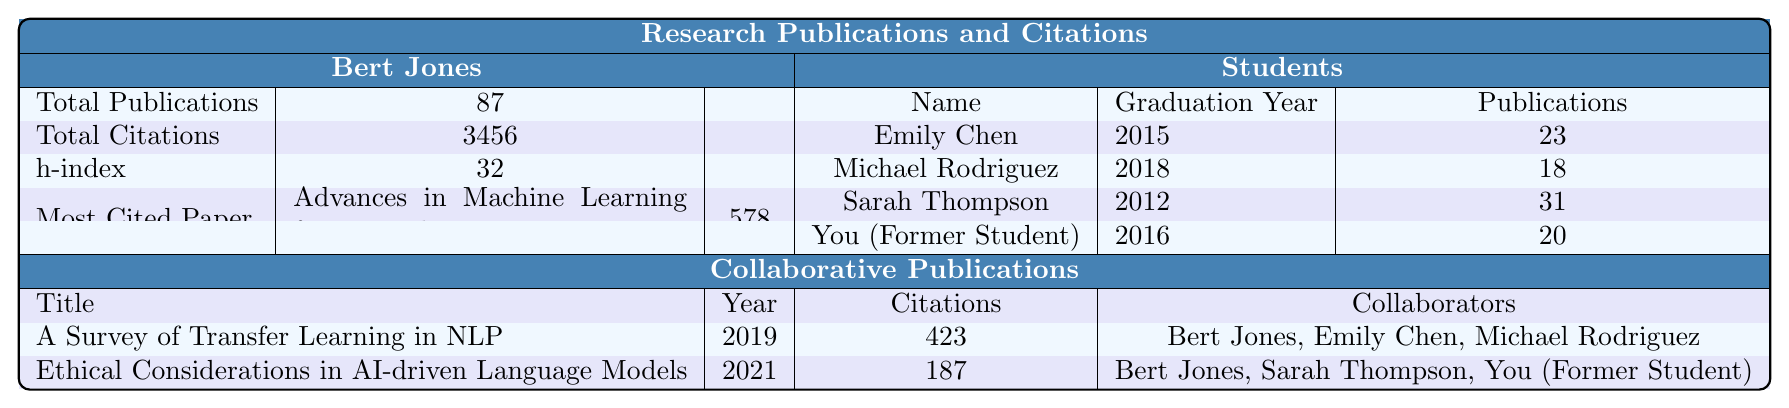What is the total number of publications by Bert Jones? The table directly states that Bert Jones has a total of 87 publications listed under "Total Publications."
Answer: 87 What is the h-index of Sarah Thompson? Looking under the "Students" section, Sarah Thompson's h-index is listed as 15.
Answer: 15 Who is the most cited among Bert Jones and his students? Bert Jones has a total of 3456 citations, while the highest cited student, Sarah Thompson, has 892 citations. Bert Jones has more citations overall.
Answer: Bert Jones What is the year of the most cited paper by Bert Jones? The most cited paper by Bert Jones titled "Advances in Machine Learning for Natural Language Processing" was published in 2009, as indicated in the "Most Cited Paper" section.
Answer: 2009 How many collaborative publications are listed in the table? The table shows two collaborative publications under the "Collaborative Publications" section, namely the papers listed with their titles and details.
Answer: 2 What is the total number of citations for Emily Chen and Michael Rodriguez combined? Emily Chen has 567 citations and Michael Rodriguez has 432 citations. Adding these gives 567 + 432 = 999 citations combined.
Answer: 999 How many students graduated after 2015? Among the students listed, only Michael Rodriguez graduated in 2018, which is after 2015.
Answer: 1 Which student's most cited paper has more than 200 citations? Sarah Thompson's most cited paper titled "Advancements in Neural Machine Translation" has 267 citations, which is more than 200.
Answer: Sarah Thompson What is the average number of publications per student? There are four students, with a total of (23 + 18 + 31 + 20) = 92 publications. The average is 92/4 = 23.
Answer: 23 Did Bert Jones collaborate with you on any publications? Yes, the table lists a collaborative publication titled "Ethical Considerations in AI-driven Language Models," indicating a collaboration between Bert Jones and you.
Answer: Yes Which student has an h-index of 12? The h-index of 12 corresponds to Emily Chen, as stated in her listing under the "Students" section.
Answer: Emily Chen What is the citation difference between Bert Jones and You (Former Student)? Bert Jones has 3456 citations while you have 389 citations. The difference is 3456 - 389 = 3067.
Answer: 3067 